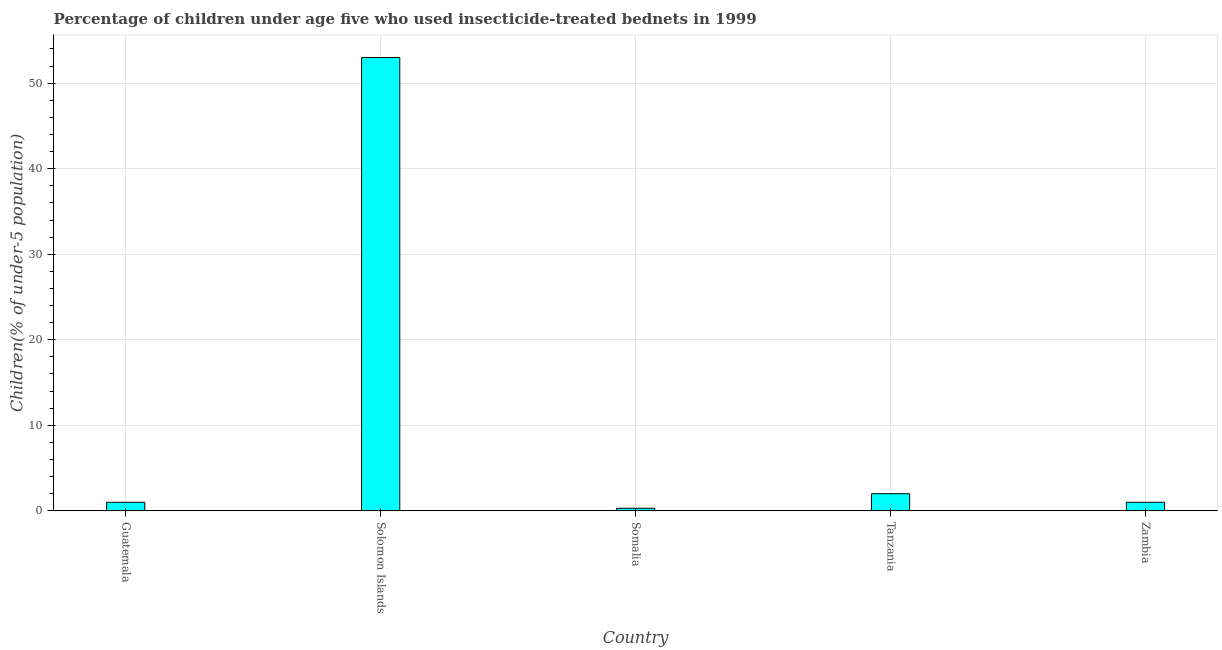Does the graph contain grids?
Ensure brevity in your answer.  Yes. What is the title of the graph?
Keep it short and to the point. Percentage of children under age five who used insecticide-treated bednets in 1999. What is the label or title of the Y-axis?
Offer a very short reply. Children(% of under-5 population). What is the percentage of children who use of insecticide-treated bed nets in Zambia?
Offer a terse response. 1. Across all countries, what is the minimum percentage of children who use of insecticide-treated bed nets?
Provide a short and direct response. 0.3. In which country was the percentage of children who use of insecticide-treated bed nets maximum?
Your response must be concise. Solomon Islands. In which country was the percentage of children who use of insecticide-treated bed nets minimum?
Offer a very short reply. Somalia. What is the sum of the percentage of children who use of insecticide-treated bed nets?
Provide a succinct answer. 57.3. What is the average percentage of children who use of insecticide-treated bed nets per country?
Give a very brief answer. 11.46. What is the ratio of the percentage of children who use of insecticide-treated bed nets in Solomon Islands to that in Somalia?
Provide a succinct answer. 176.67. Is the difference between the percentage of children who use of insecticide-treated bed nets in Guatemala and Somalia greater than the difference between any two countries?
Keep it short and to the point. No. Is the sum of the percentage of children who use of insecticide-treated bed nets in Somalia and Zambia greater than the maximum percentage of children who use of insecticide-treated bed nets across all countries?
Provide a short and direct response. No. What is the difference between the highest and the lowest percentage of children who use of insecticide-treated bed nets?
Offer a terse response. 52.7. In how many countries, is the percentage of children who use of insecticide-treated bed nets greater than the average percentage of children who use of insecticide-treated bed nets taken over all countries?
Your answer should be very brief. 1. Are all the bars in the graph horizontal?
Your answer should be very brief. No. What is the Children(% of under-5 population) of Guatemala?
Keep it short and to the point. 1. What is the Children(% of under-5 population) in Solomon Islands?
Ensure brevity in your answer.  53. What is the Children(% of under-5 population) in Somalia?
Offer a terse response. 0.3. What is the Children(% of under-5 population) in Zambia?
Offer a terse response. 1. What is the difference between the Children(% of under-5 population) in Guatemala and Solomon Islands?
Offer a terse response. -52. What is the difference between the Children(% of under-5 population) in Guatemala and Somalia?
Offer a very short reply. 0.7. What is the difference between the Children(% of under-5 population) in Guatemala and Tanzania?
Offer a very short reply. -1. What is the difference between the Children(% of under-5 population) in Solomon Islands and Somalia?
Make the answer very short. 52.7. What is the difference between the Children(% of under-5 population) in Solomon Islands and Tanzania?
Offer a terse response. 51. What is the difference between the Children(% of under-5 population) in Somalia and Tanzania?
Ensure brevity in your answer.  -1.7. What is the ratio of the Children(% of under-5 population) in Guatemala to that in Solomon Islands?
Provide a succinct answer. 0.02. What is the ratio of the Children(% of under-5 population) in Guatemala to that in Somalia?
Ensure brevity in your answer.  3.33. What is the ratio of the Children(% of under-5 population) in Guatemala to that in Zambia?
Your response must be concise. 1. What is the ratio of the Children(% of under-5 population) in Solomon Islands to that in Somalia?
Your answer should be compact. 176.67. What is the ratio of the Children(% of under-5 population) in Tanzania to that in Zambia?
Make the answer very short. 2. 